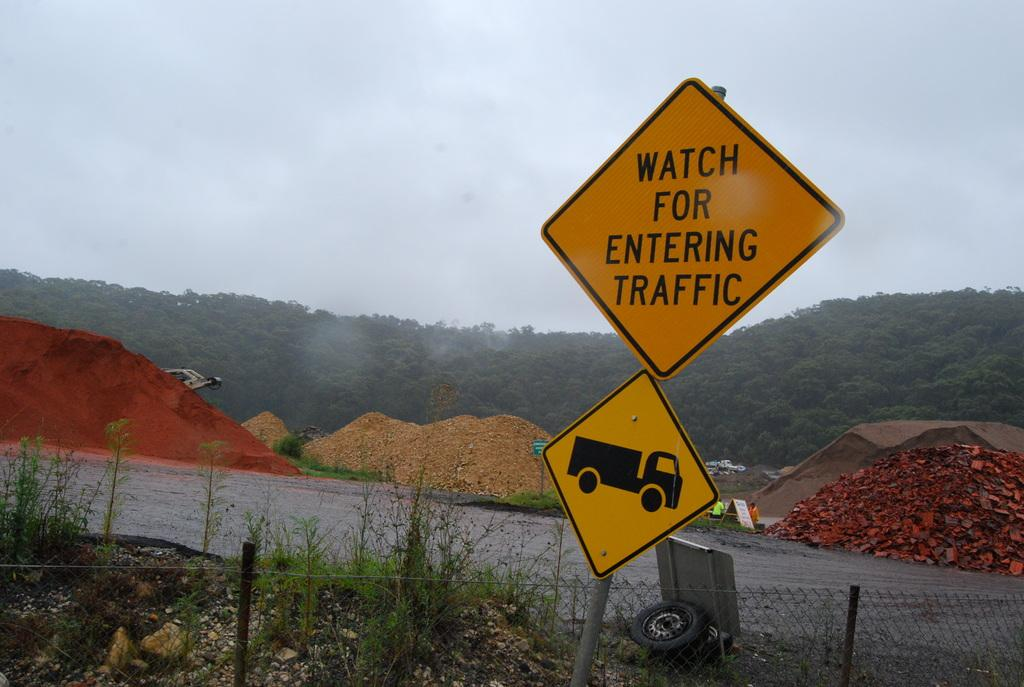<image>
Share a concise interpretation of the image provided. A sign that reads Watch for Entering Traffic in black on yellow. 